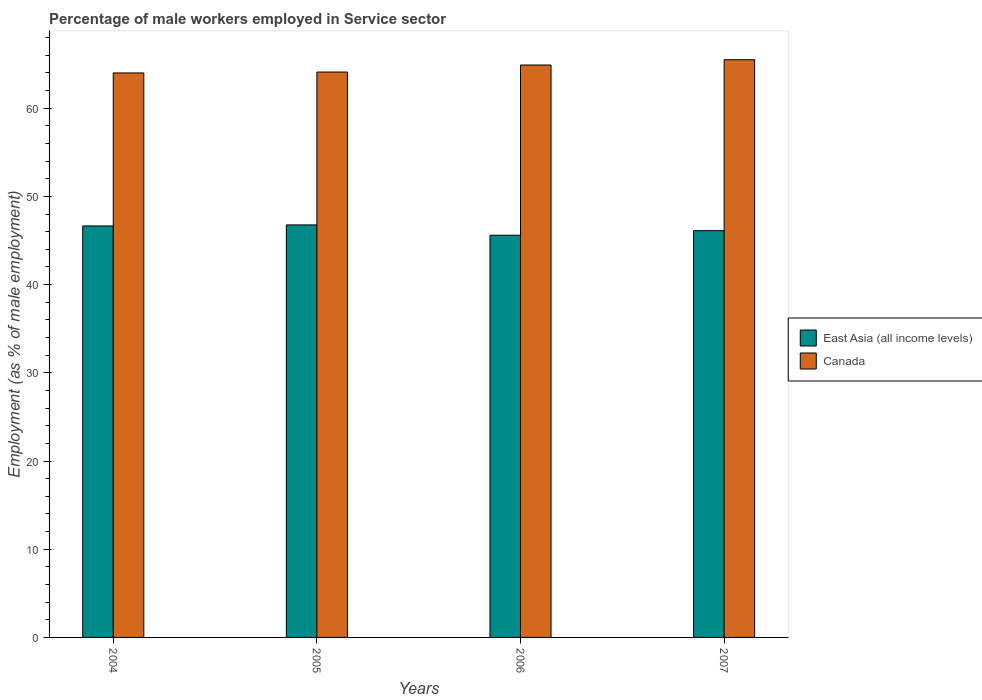How many groups of bars are there?
Your response must be concise. 4. How many bars are there on the 1st tick from the left?
Offer a terse response. 2. In how many cases, is the number of bars for a given year not equal to the number of legend labels?
Give a very brief answer. 0. What is the percentage of male workers employed in Service sector in East Asia (all income levels) in 2006?
Offer a terse response. 45.6. Across all years, what is the maximum percentage of male workers employed in Service sector in East Asia (all income levels)?
Offer a terse response. 46.77. Across all years, what is the minimum percentage of male workers employed in Service sector in East Asia (all income levels)?
Provide a succinct answer. 45.6. In which year was the percentage of male workers employed in Service sector in East Asia (all income levels) maximum?
Your answer should be very brief. 2005. What is the total percentage of male workers employed in Service sector in Canada in the graph?
Give a very brief answer. 258.5. What is the difference between the percentage of male workers employed in Service sector in Canada in 2006 and that in 2007?
Your answer should be compact. -0.6. What is the difference between the percentage of male workers employed in Service sector in Canada in 2007 and the percentage of male workers employed in Service sector in East Asia (all income levels) in 2005?
Keep it short and to the point. 18.73. What is the average percentage of male workers employed in Service sector in East Asia (all income levels) per year?
Offer a very short reply. 46.29. In the year 2005, what is the difference between the percentage of male workers employed in Service sector in Canada and percentage of male workers employed in Service sector in East Asia (all income levels)?
Provide a short and direct response. 17.33. What is the ratio of the percentage of male workers employed in Service sector in East Asia (all income levels) in 2005 to that in 2007?
Provide a short and direct response. 1.01. Is the percentage of male workers employed in Service sector in East Asia (all income levels) in 2006 less than that in 2007?
Make the answer very short. Yes. Is the difference between the percentage of male workers employed in Service sector in Canada in 2005 and 2006 greater than the difference between the percentage of male workers employed in Service sector in East Asia (all income levels) in 2005 and 2006?
Give a very brief answer. No. What is the difference between the highest and the second highest percentage of male workers employed in Service sector in East Asia (all income levels)?
Give a very brief answer. 0.12. What is the difference between the highest and the lowest percentage of male workers employed in Service sector in Canada?
Your answer should be very brief. 1.5. In how many years, is the percentage of male workers employed in Service sector in East Asia (all income levels) greater than the average percentage of male workers employed in Service sector in East Asia (all income levels) taken over all years?
Make the answer very short. 2. What does the 2nd bar from the right in 2004 represents?
Your answer should be very brief. East Asia (all income levels). How many bars are there?
Ensure brevity in your answer.  8. Are the values on the major ticks of Y-axis written in scientific E-notation?
Offer a very short reply. No. Does the graph contain grids?
Offer a very short reply. No. Where does the legend appear in the graph?
Your answer should be very brief. Center right. How many legend labels are there?
Give a very brief answer. 2. What is the title of the graph?
Make the answer very short. Percentage of male workers employed in Service sector. What is the label or title of the X-axis?
Your response must be concise. Years. What is the label or title of the Y-axis?
Offer a terse response. Employment (as % of male employment). What is the Employment (as % of male employment) of East Asia (all income levels) in 2004?
Your answer should be very brief. 46.65. What is the Employment (as % of male employment) of East Asia (all income levels) in 2005?
Your answer should be very brief. 46.77. What is the Employment (as % of male employment) of Canada in 2005?
Offer a terse response. 64.1. What is the Employment (as % of male employment) in East Asia (all income levels) in 2006?
Ensure brevity in your answer.  45.6. What is the Employment (as % of male employment) in Canada in 2006?
Offer a very short reply. 64.9. What is the Employment (as % of male employment) of East Asia (all income levels) in 2007?
Offer a terse response. 46.12. What is the Employment (as % of male employment) of Canada in 2007?
Provide a short and direct response. 65.5. Across all years, what is the maximum Employment (as % of male employment) in East Asia (all income levels)?
Provide a succinct answer. 46.77. Across all years, what is the maximum Employment (as % of male employment) in Canada?
Ensure brevity in your answer.  65.5. Across all years, what is the minimum Employment (as % of male employment) in East Asia (all income levels)?
Make the answer very short. 45.6. What is the total Employment (as % of male employment) of East Asia (all income levels) in the graph?
Make the answer very short. 185.14. What is the total Employment (as % of male employment) in Canada in the graph?
Ensure brevity in your answer.  258.5. What is the difference between the Employment (as % of male employment) of East Asia (all income levels) in 2004 and that in 2005?
Provide a succinct answer. -0.12. What is the difference between the Employment (as % of male employment) in East Asia (all income levels) in 2004 and that in 2006?
Offer a terse response. 1.05. What is the difference between the Employment (as % of male employment) of Canada in 2004 and that in 2006?
Offer a terse response. -0.9. What is the difference between the Employment (as % of male employment) in East Asia (all income levels) in 2004 and that in 2007?
Your answer should be compact. 0.53. What is the difference between the Employment (as % of male employment) in Canada in 2004 and that in 2007?
Offer a terse response. -1.5. What is the difference between the Employment (as % of male employment) of East Asia (all income levels) in 2005 and that in 2006?
Make the answer very short. 1.17. What is the difference between the Employment (as % of male employment) of Canada in 2005 and that in 2006?
Offer a terse response. -0.8. What is the difference between the Employment (as % of male employment) in East Asia (all income levels) in 2005 and that in 2007?
Offer a very short reply. 0.65. What is the difference between the Employment (as % of male employment) of Canada in 2005 and that in 2007?
Provide a short and direct response. -1.4. What is the difference between the Employment (as % of male employment) in East Asia (all income levels) in 2006 and that in 2007?
Give a very brief answer. -0.52. What is the difference between the Employment (as % of male employment) of Canada in 2006 and that in 2007?
Offer a terse response. -0.6. What is the difference between the Employment (as % of male employment) in East Asia (all income levels) in 2004 and the Employment (as % of male employment) in Canada in 2005?
Offer a terse response. -17.45. What is the difference between the Employment (as % of male employment) in East Asia (all income levels) in 2004 and the Employment (as % of male employment) in Canada in 2006?
Your response must be concise. -18.25. What is the difference between the Employment (as % of male employment) of East Asia (all income levels) in 2004 and the Employment (as % of male employment) of Canada in 2007?
Your response must be concise. -18.85. What is the difference between the Employment (as % of male employment) in East Asia (all income levels) in 2005 and the Employment (as % of male employment) in Canada in 2006?
Offer a very short reply. -18.13. What is the difference between the Employment (as % of male employment) in East Asia (all income levels) in 2005 and the Employment (as % of male employment) in Canada in 2007?
Provide a succinct answer. -18.73. What is the difference between the Employment (as % of male employment) in East Asia (all income levels) in 2006 and the Employment (as % of male employment) in Canada in 2007?
Offer a very short reply. -19.9. What is the average Employment (as % of male employment) in East Asia (all income levels) per year?
Your answer should be very brief. 46.29. What is the average Employment (as % of male employment) of Canada per year?
Your answer should be very brief. 64.62. In the year 2004, what is the difference between the Employment (as % of male employment) of East Asia (all income levels) and Employment (as % of male employment) of Canada?
Keep it short and to the point. -17.35. In the year 2005, what is the difference between the Employment (as % of male employment) of East Asia (all income levels) and Employment (as % of male employment) of Canada?
Keep it short and to the point. -17.33. In the year 2006, what is the difference between the Employment (as % of male employment) of East Asia (all income levels) and Employment (as % of male employment) of Canada?
Offer a very short reply. -19.3. In the year 2007, what is the difference between the Employment (as % of male employment) of East Asia (all income levels) and Employment (as % of male employment) of Canada?
Your response must be concise. -19.38. What is the ratio of the Employment (as % of male employment) in East Asia (all income levels) in 2004 to that in 2006?
Offer a terse response. 1.02. What is the ratio of the Employment (as % of male employment) of Canada in 2004 to that in 2006?
Keep it short and to the point. 0.99. What is the ratio of the Employment (as % of male employment) of East Asia (all income levels) in 2004 to that in 2007?
Ensure brevity in your answer.  1.01. What is the ratio of the Employment (as % of male employment) of Canada in 2004 to that in 2007?
Give a very brief answer. 0.98. What is the ratio of the Employment (as % of male employment) in East Asia (all income levels) in 2005 to that in 2006?
Provide a succinct answer. 1.03. What is the ratio of the Employment (as % of male employment) in Canada in 2005 to that in 2006?
Provide a succinct answer. 0.99. What is the ratio of the Employment (as % of male employment) in East Asia (all income levels) in 2005 to that in 2007?
Provide a succinct answer. 1.01. What is the ratio of the Employment (as % of male employment) in Canada in 2005 to that in 2007?
Your answer should be very brief. 0.98. What is the difference between the highest and the second highest Employment (as % of male employment) in East Asia (all income levels)?
Provide a short and direct response. 0.12. What is the difference between the highest and the lowest Employment (as % of male employment) of East Asia (all income levels)?
Make the answer very short. 1.17. What is the difference between the highest and the lowest Employment (as % of male employment) of Canada?
Make the answer very short. 1.5. 